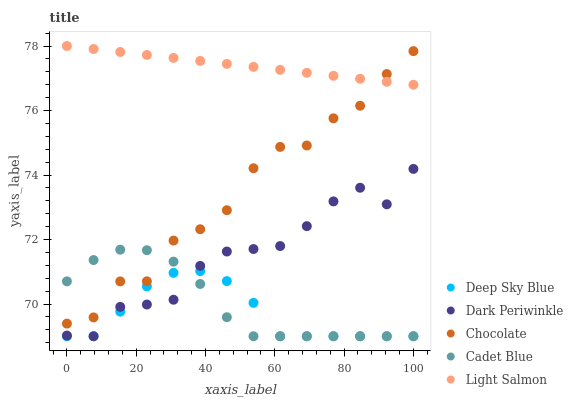Does Deep Sky Blue have the minimum area under the curve?
Answer yes or no. Yes. Does Light Salmon have the maximum area under the curve?
Answer yes or no. Yes. Does Cadet Blue have the minimum area under the curve?
Answer yes or no. No. Does Cadet Blue have the maximum area under the curve?
Answer yes or no. No. Is Light Salmon the smoothest?
Answer yes or no. Yes. Is Chocolate the roughest?
Answer yes or no. Yes. Is Cadet Blue the smoothest?
Answer yes or no. No. Is Cadet Blue the roughest?
Answer yes or no. No. Does Cadet Blue have the lowest value?
Answer yes or no. Yes. Does Chocolate have the lowest value?
Answer yes or no. No. Does Light Salmon have the highest value?
Answer yes or no. Yes. Does Cadet Blue have the highest value?
Answer yes or no. No. Is Deep Sky Blue less than Light Salmon?
Answer yes or no. Yes. Is Chocolate greater than Deep Sky Blue?
Answer yes or no. Yes. Does Dark Periwinkle intersect Cadet Blue?
Answer yes or no. Yes. Is Dark Periwinkle less than Cadet Blue?
Answer yes or no. No. Is Dark Periwinkle greater than Cadet Blue?
Answer yes or no. No. Does Deep Sky Blue intersect Light Salmon?
Answer yes or no. No. 